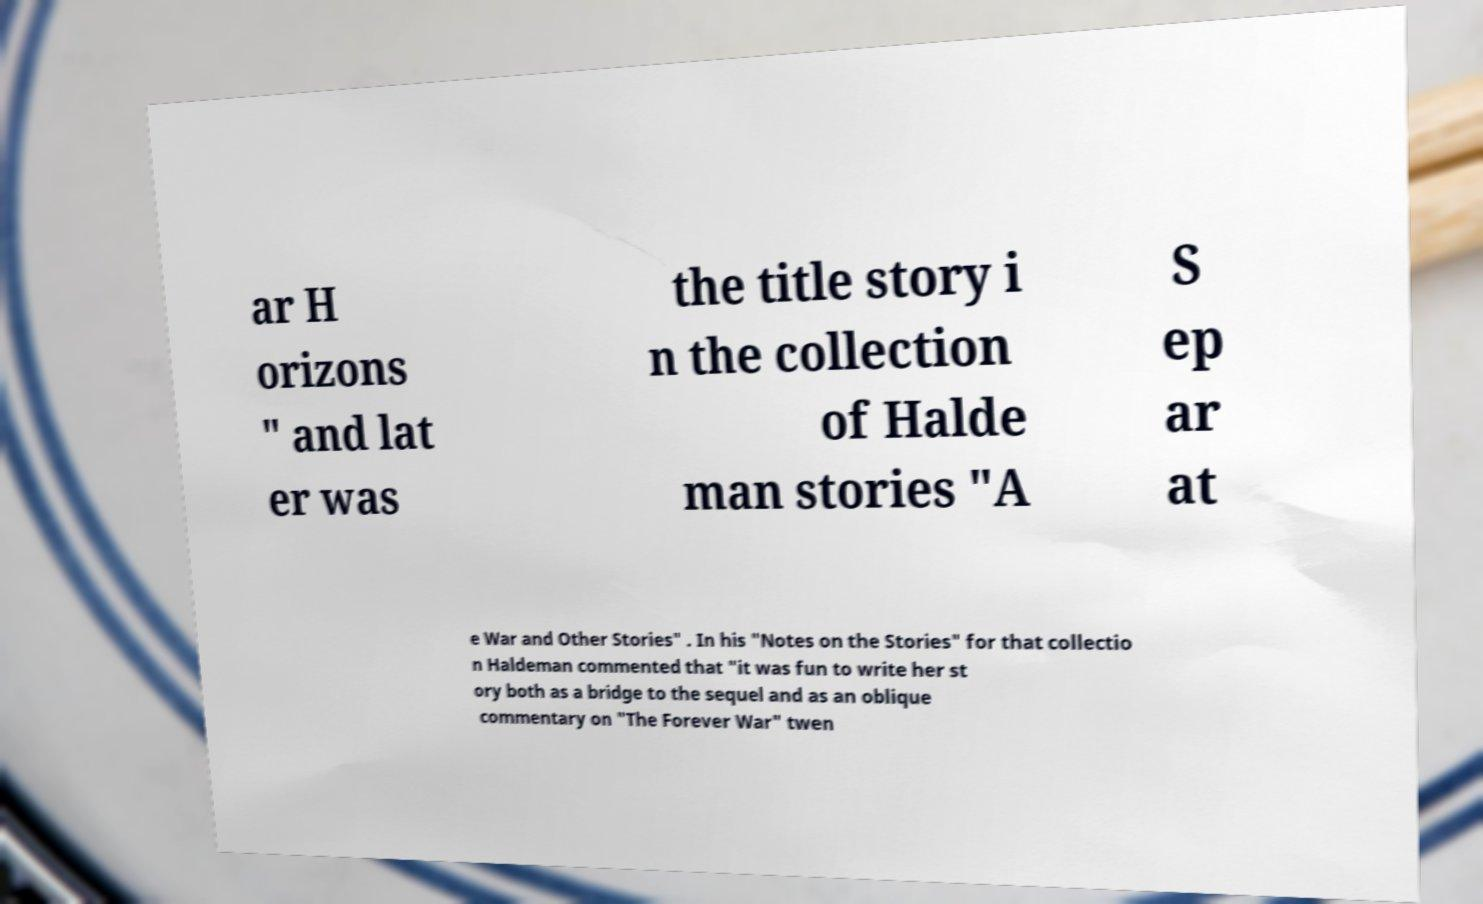For documentation purposes, I need the text within this image transcribed. Could you provide that? ar H orizons " and lat er was the title story i n the collection of Halde man stories "A S ep ar at e War and Other Stories" . In his "Notes on the Stories" for that collectio n Haldeman commented that "it was fun to write her st ory both as a bridge to the sequel and as an oblique commentary on "The Forever War" twen 